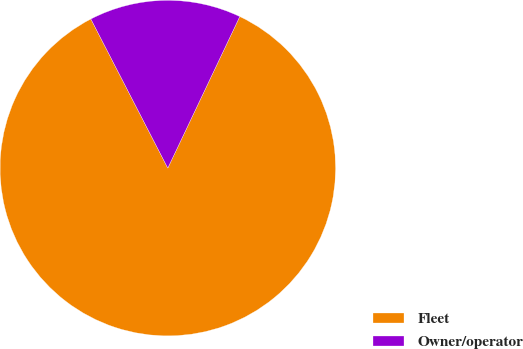Convert chart. <chart><loc_0><loc_0><loc_500><loc_500><pie_chart><fcel>Fleet<fcel>Owner/operator<nl><fcel>85.36%<fcel>14.64%<nl></chart> 